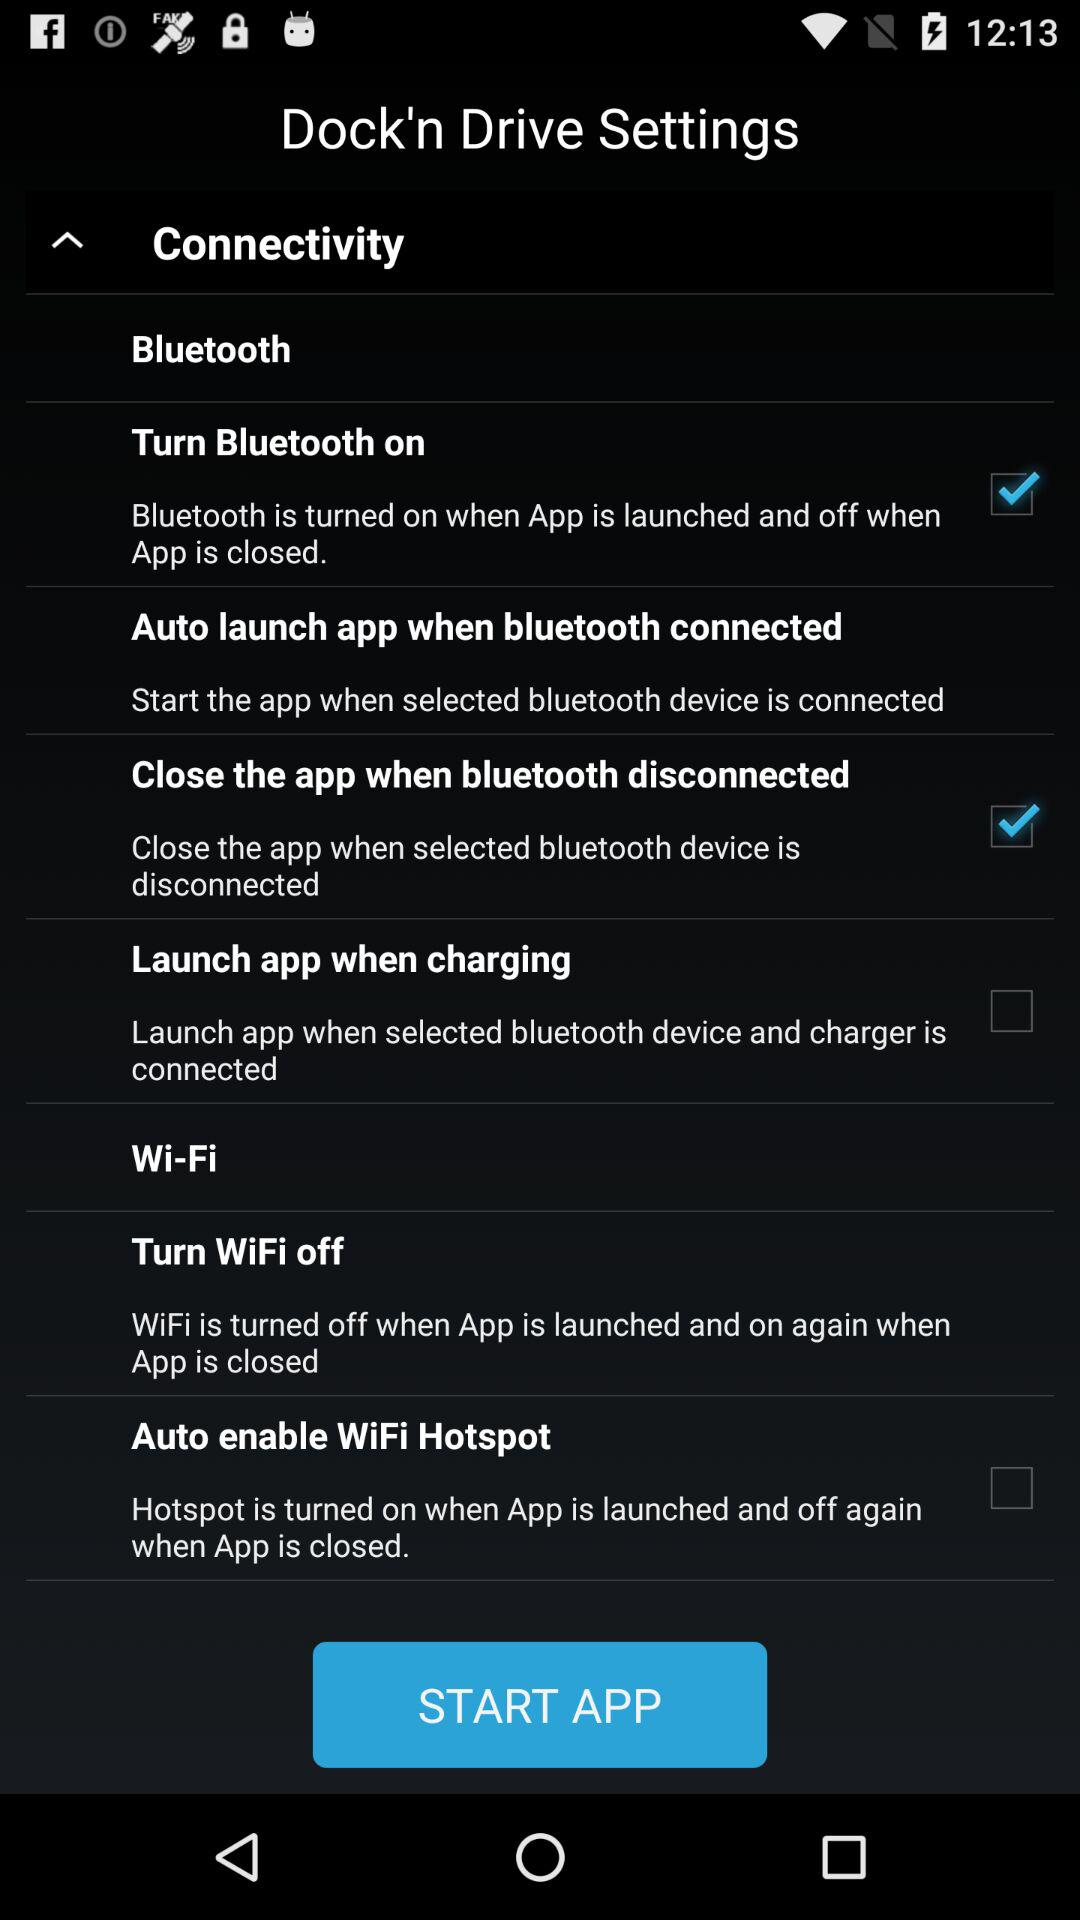Which settings are checked? The checked settings are "Turn Bluetooth on" and "Close the app when bluetooth disconnected". 